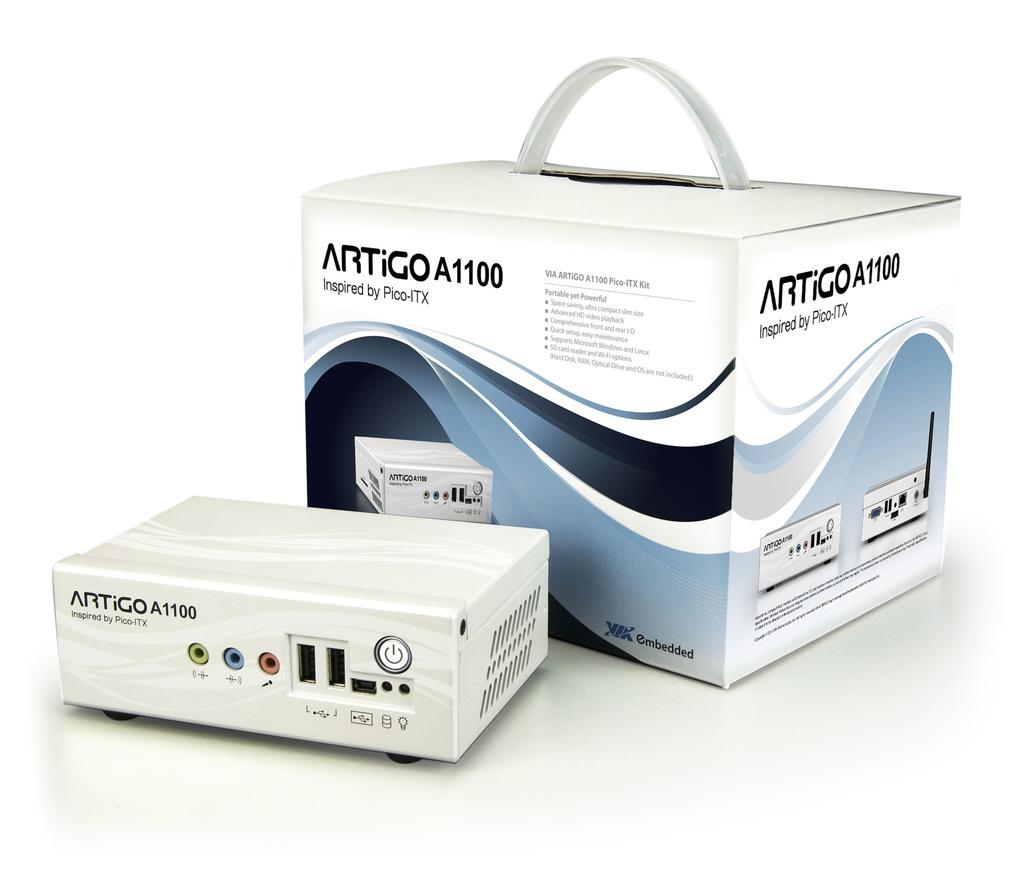<image>
Summarize the visual content of the image. A box with a handle and the equipment in front of the box are inspired by Pico-ITX. 